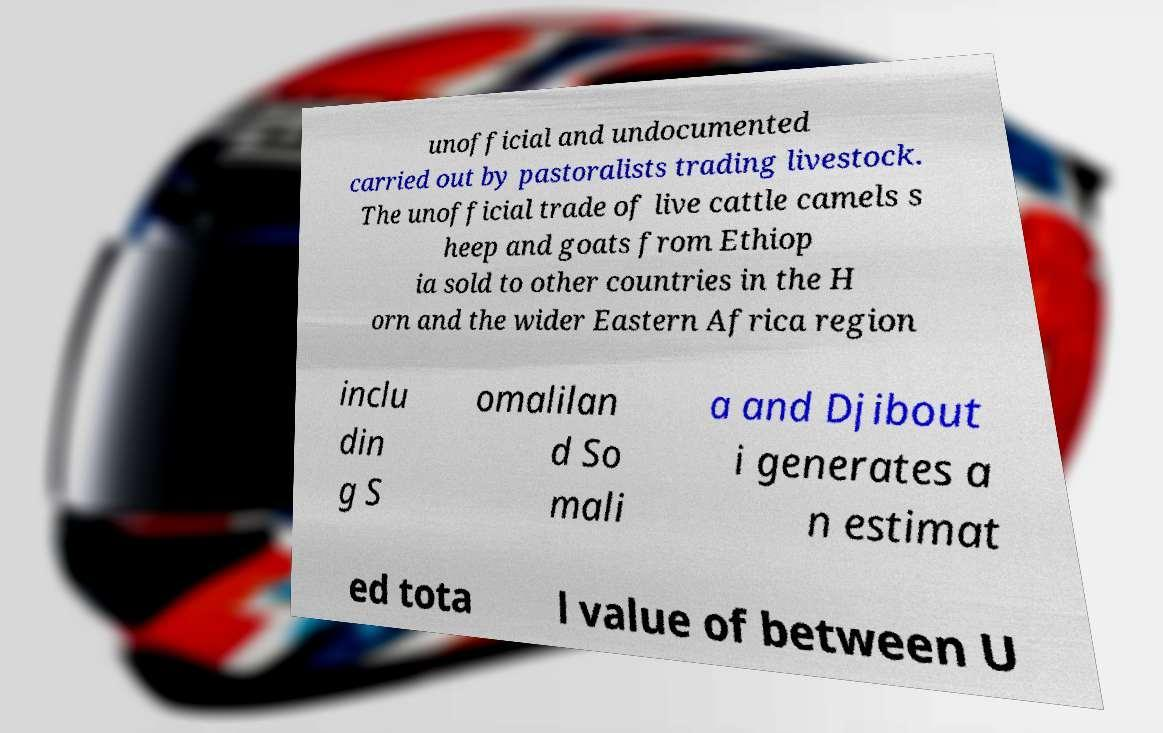Please identify and transcribe the text found in this image. unofficial and undocumented carried out by pastoralists trading livestock. The unofficial trade of live cattle camels s heep and goats from Ethiop ia sold to other countries in the H orn and the wider Eastern Africa region inclu din g S omalilan d So mali a and Djibout i generates a n estimat ed tota l value of between U 